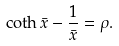<formula> <loc_0><loc_0><loc_500><loc_500>\coth \bar { x } - \frac { 1 } { \bar { x } } = \rho .</formula> 